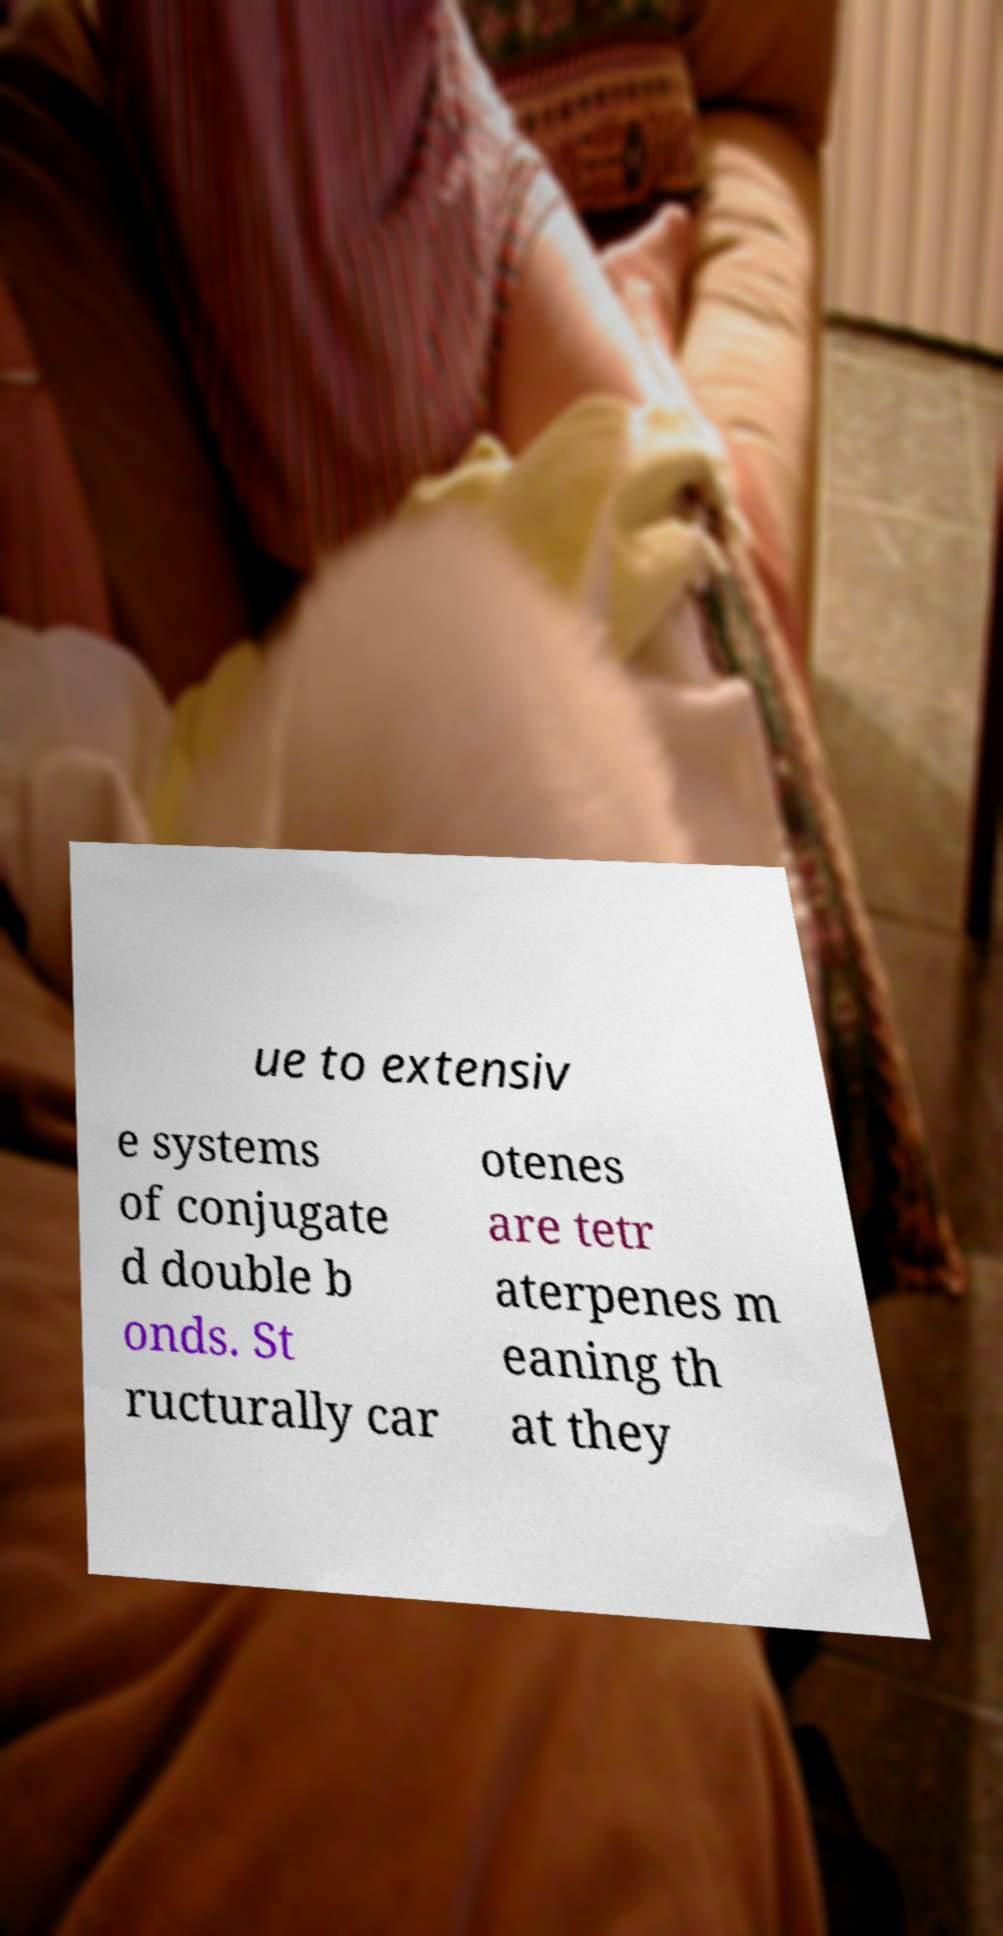Please identify and transcribe the text found in this image. ue to extensiv e systems of conjugate d double b onds. St ructurally car otenes are tetr aterpenes m eaning th at they 